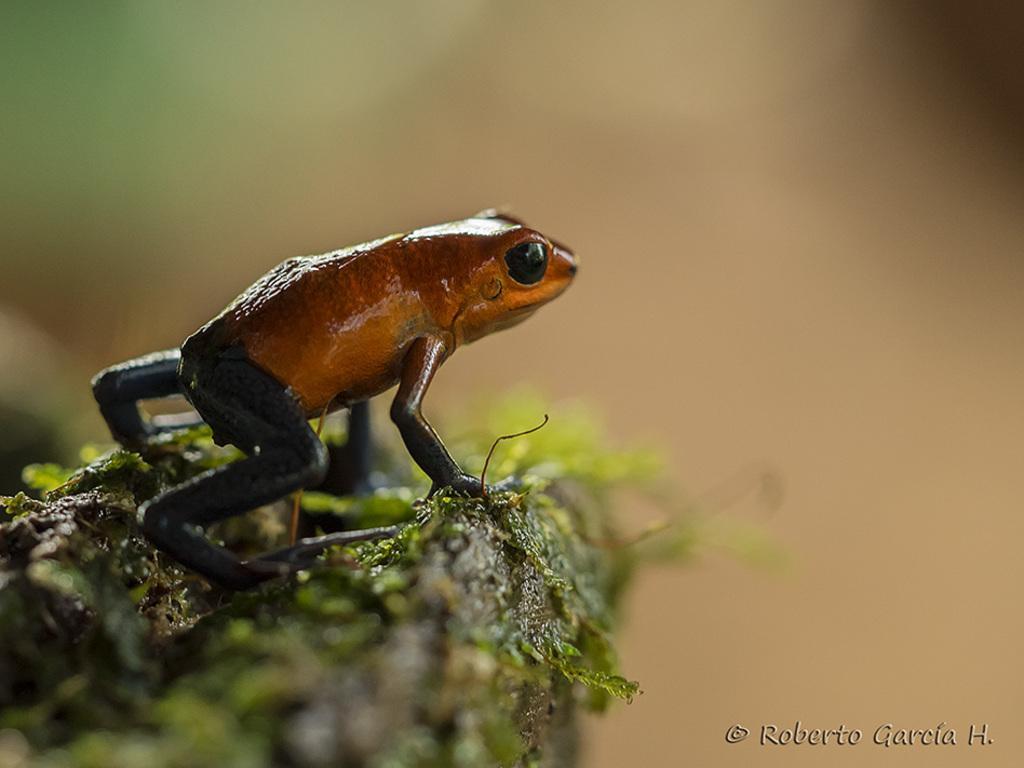Describe this image in one or two sentences. In this picture we can see a frog on the path and behind the frog there is a blurred background and on the image there is a watermark. 